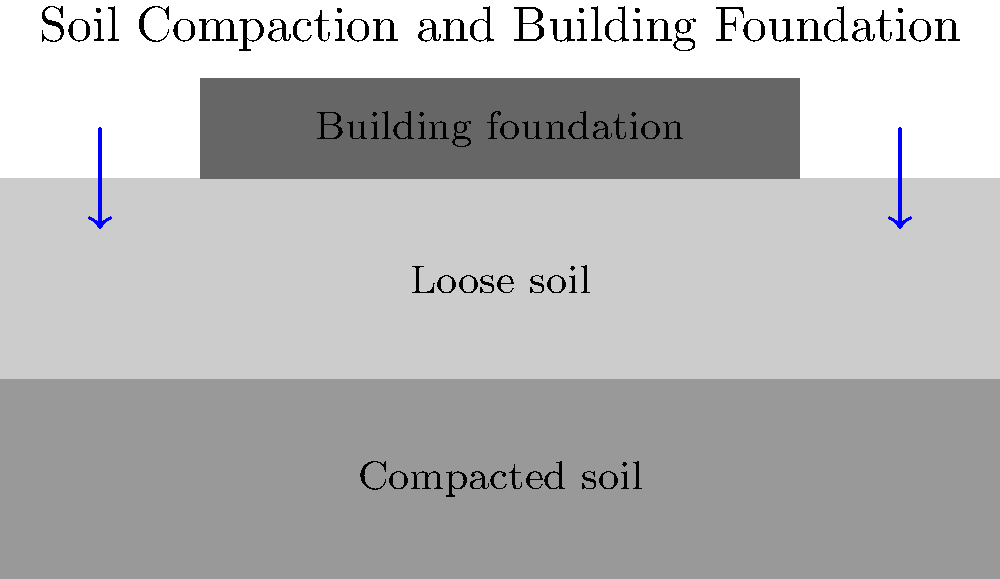During your late-night study session on criminal justice, you come across a case involving structural damage to a police station. The damage is attributed to improper soil compaction. Based on the diagram, which shows two soil layers beneath a building foundation, explain how inadequate soil compaction in the loose soil layer could affect the building's stability over time. To understand how inadequate soil compaction affects building stability, let's break it down step-by-step:

1. Soil Layers: The diagram shows two distinct soil layers beneath the building foundation:
   a) A lower layer of compacted soil
   b) An upper layer of loose soil

2. Compaction Process: Soil compaction involves reducing the air voids between soil particles, increasing density and stability.

3. Importance of Compaction:
   a) Compacted soil provides a stable base for foundations
   b) It reduces settlement and prevents uneven sinking of structures

4. Effects of Loose Soil:
   a) Loose soil contains more air voids, making it susceptible to compression under load
   b) When a building's weight is applied, loose soil tends to settle unevenly

5. Settlement Process:
   a) Over time, the weight of the building causes the loose soil to compact
   b) This leads to gradual, often uneven, sinking of the foundation

6. Consequences:
   a) Uneven settlement can cause structural stress and damage
   b) It may result in cracks in walls, floors, or the foundation itself
   c) Doors and windows might become misaligned
   d) In severe cases, it could compromise the building's overall integrity

7. Prevention:
   a) Proper soil testing and preparation before construction
   b) Adequate compaction of all soil layers, especially those directly beneath the foundation

8. Relevance to Criminal Justice:
   a) Structural integrity is crucial for police stations and other law enforcement facilities
   b) Building failures due to soil issues could lead to legal and safety concerns

In this case, the loose soil layer beneath the police station's foundation likely led to uneven settlement, causing the observed structural damage.
Answer: Inadequate soil compaction leads to uneven settlement, causing structural damage over time. 